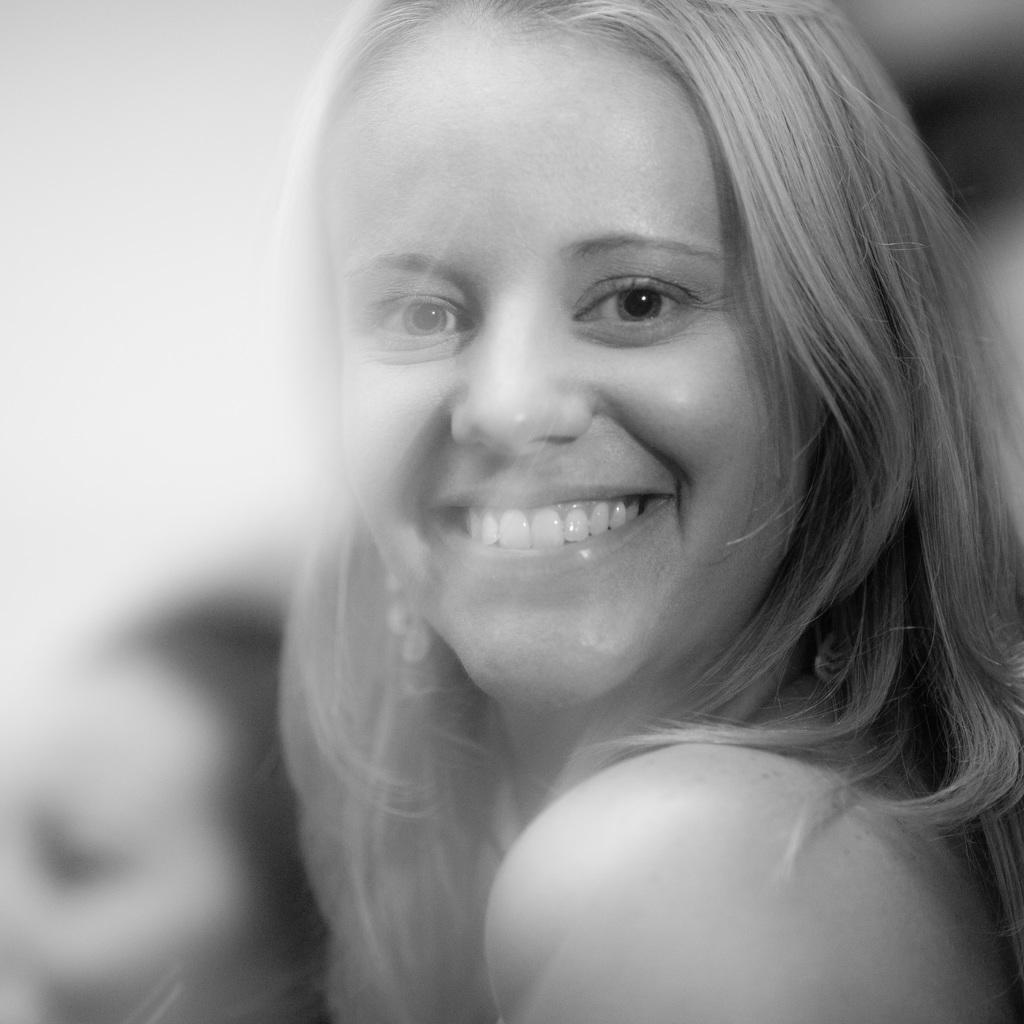Who is the main subject in the image? There is a lady in the image. Where is the lady positioned in the image? The lady is in the center of the image. What is the lady's facial expression in the image? The lady is smiling in the image. What color is the sofa behind the lady in the image? There is no sofa present in the image. How many thumbs does the lady have in the image? The number of thumbs the lady has cannot be determined from the image, as it only shows her face and upper body. 